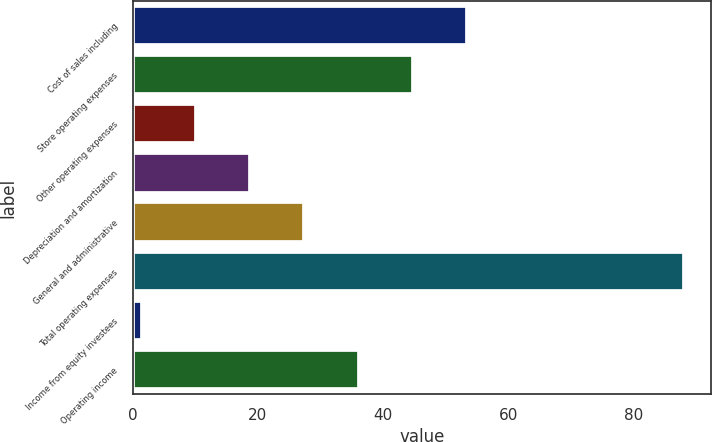Convert chart to OTSL. <chart><loc_0><loc_0><loc_500><loc_500><bar_chart><fcel>Cost of sales including<fcel>Store operating expenses<fcel>Other operating expenses<fcel>Depreciation and amortization<fcel>General and administrative<fcel>Total operating expenses<fcel>Income from equity investees<fcel>Operating income<nl><fcel>53.42<fcel>44.75<fcel>10.07<fcel>18.74<fcel>27.41<fcel>88.1<fcel>1.4<fcel>36.08<nl></chart> 